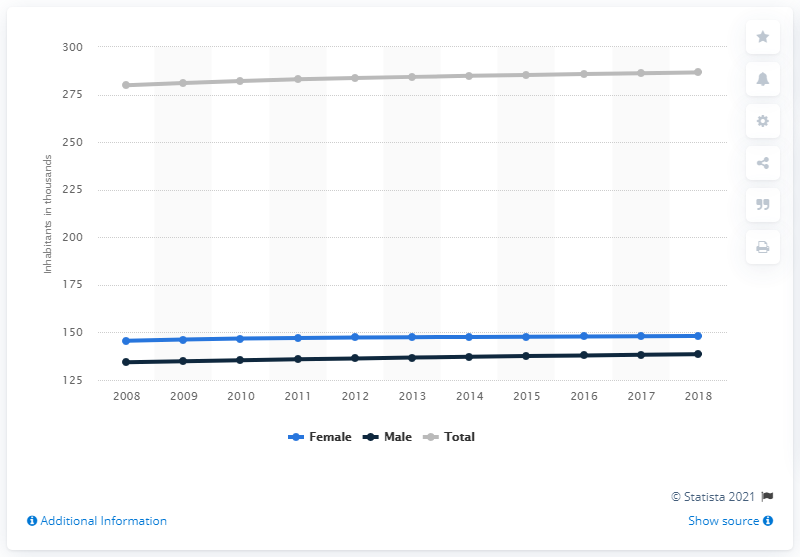List a handful of essential elements in this visual. The population of Barbados began to show an upward trend in 2008. 